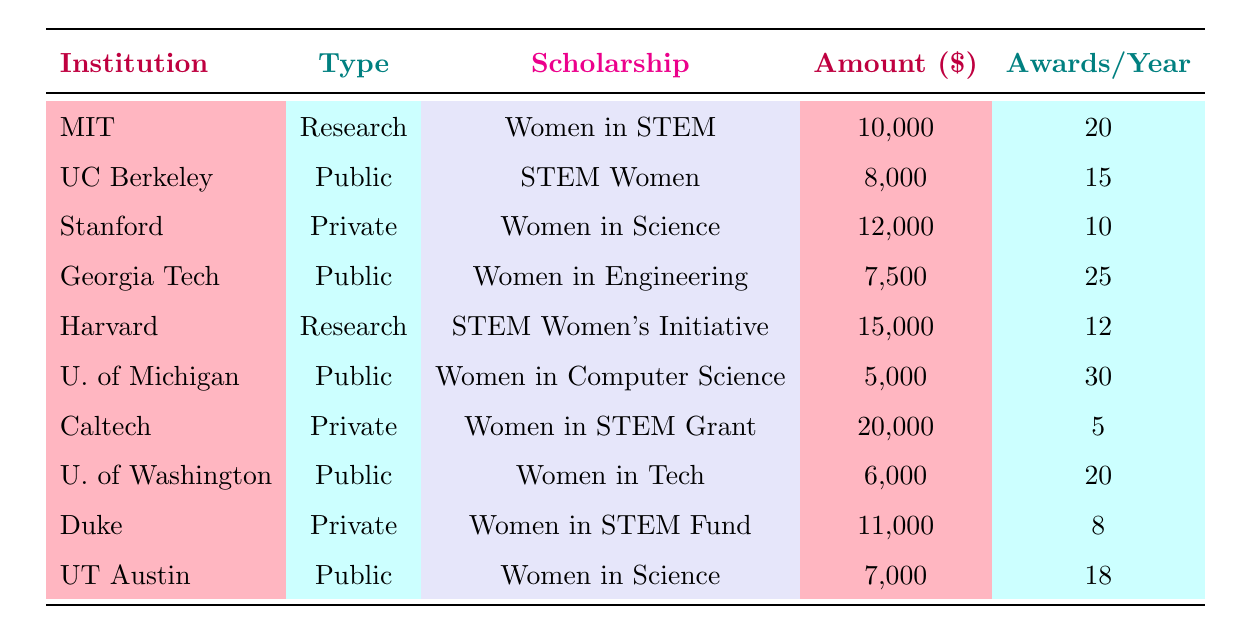What is the scholarship amount offered by Harvard University? The table directly lists the scholarship offered by Harvard University as the "STEM Women's Initiative," which has an amount of 15,000 dollars.
Answer: 15,000 Which institution offers the highest scholarship amount for female STEM students? By examining the amounts listed across all institutions, Caltech offers the highest amount of 20,000 dollars for the "Women in STEM Grant."
Answer: Caltech How many awards per year are offered by the University of Michigan? The table indicates that the "Women in Computer Science Scholarship" at the University of Michigan awards 30 scholarships per year.
Answer: 30 Is it true that all private universities listed offer scholarships for female STEM students? The data reviewed shows that all private universities, including Stanford, Caltech, and Duke, have scholarships specifically designated for female students in STEM, confirming this statement to be true.
Answer: Yes What is the total number of awards per year from public universities listed in the table? The awards per year for the public universities are summed up as follows: 15 (UC Berkeley) + 25 (Georgia Tech) + 30 (U. of Michigan) + 20 (U. of Washington) + 18 (UT Austin) = 108 total awards per year.
Answer: 108 Which institution has the earliest application deadline, and when is it? Evaluating the application deadlines of each scholarship, Harvard University has the earliest deadline on January 15, 2024, for its scholarship.
Answer: Harvard University, January 15, 2024 Calculate the average scholarship amount offered by public universities. The total scholarship amounts for public universities are 8,000 (UC Berkeley) + 7,500 (Georgia Tech) + 5,000 (U. of Michigan) + 6,000 (U. of Washington) + 7,000 (UT Austin) = 33,500 dollars, divided by the number of public universities (5) gives an average of 6,700 dollars.
Answer: 6,700 How many awards per year does Duke University offer compared to MIT? Duke University offers 8 awards per year for the "Women in STEM Fund," while MIT offers 20 awards per year. Compared to MIT, Duke offers 12 fewer awards (20 - 8 = 12).
Answer: 12 What is the eligibility criterion for the scholarship at Georgia Institute of Technology? The scholarship at Georgia Institute of Technology, named "Women in Engineering Scholarship," requires eligible applicants to be female students enrolled in engineering programs.
Answer: Female students in engineering programs 